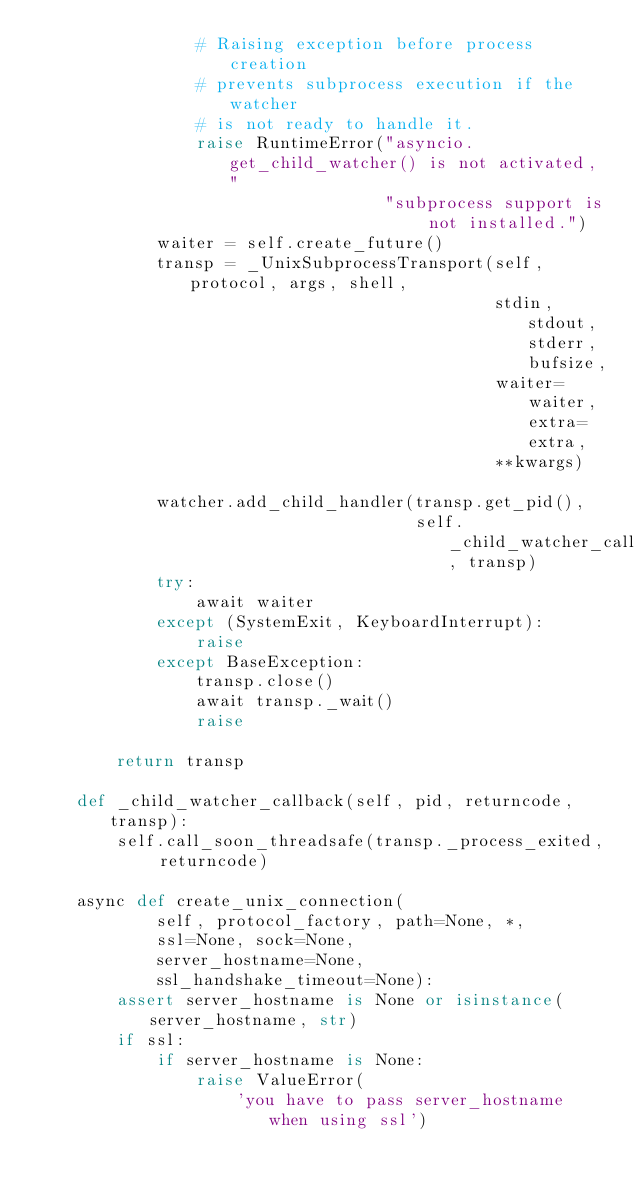<code> <loc_0><loc_0><loc_500><loc_500><_Python_>                # Raising exception before process creation
                # prevents subprocess execution if the watcher
                # is not ready to handle it.
                raise RuntimeError("asyncio.get_child_watcher() is not activated, "
                                   "subprocess support is not installed.")
            waiter = self.create_future()
            transp = _UnixSubprocessTransport(self, protocol, args, shell,
                                              stdin, stdout, stderr, bufsize,
                                              waiter=waiter, extra=extra,
                                              **kwargs)

            watcher.add_child_handler(transp.get_pid(),
                                      self._child_watcher_callback, transp)
            try:
                await waiter
            except (SystemExit, KeyboardInterrupt):
                raise
            except BaseException:
                transp.close()
                await transp._wait()
                raise

        return transp

    def _child_watcher_callback(self, pid, returncode, transp):
        self.call_soon_threadsafe(transp._process_exited, returncode)

    async def create_unix_connection(
            self, protocol_factory, path=None, *,
            ssl=None, sock=None,
            server_hostname=None,
            ssl_handshake_timeout=None):
        assert server_hostname is None or isinstance(server_hostname, str)
        if ssl:
            if server_hostname is None:
                raise ValueError(
                    'you have to pass server_hostname when using ssl')</code> 